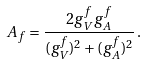Convert formula to latex. <formula><loc_0><loc_0><loc_500><loc_500>A _ { f } = \frac { 2 g _ { V } ^ { f } g _ { A } ^ { f } } { ( g _ { V } ^ { f } ) ^ { 2 } + ( g _ { A } ^ { f } ) ^ { 2 } } \, .</formula> 